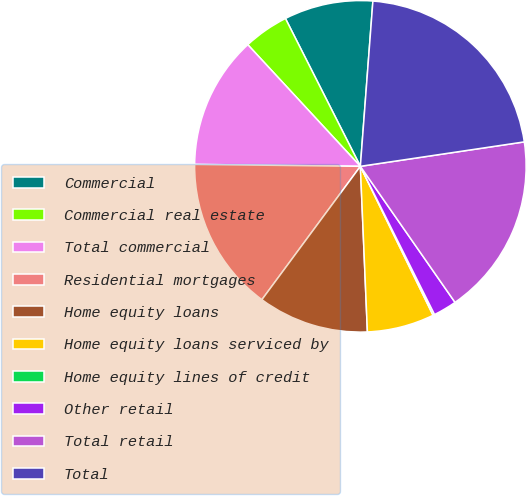Convert chart to OTSL. <chart><loc_0><loc_0><loc_500><loc_500><pie_chart><fcel>Commercial<fcel>Commercial real estate<fcel>Total commercial<fcel>Residential mortgages<fcel>Home equity loans<fcel>Home equity loans serviced by<fcel>Home equity lines of credit<fcel>Other retail<fcel>Total retail<fcel>Total<nl><fcel>8.67%<fcel>4.42%<fcel>12.93%<fcel>15.06%<fcel>10.8%<fcel>6.55%<fcel>0.16%<fcel>2.29%<fcel>17.68%<fcel>21.44%<nl></chart> 